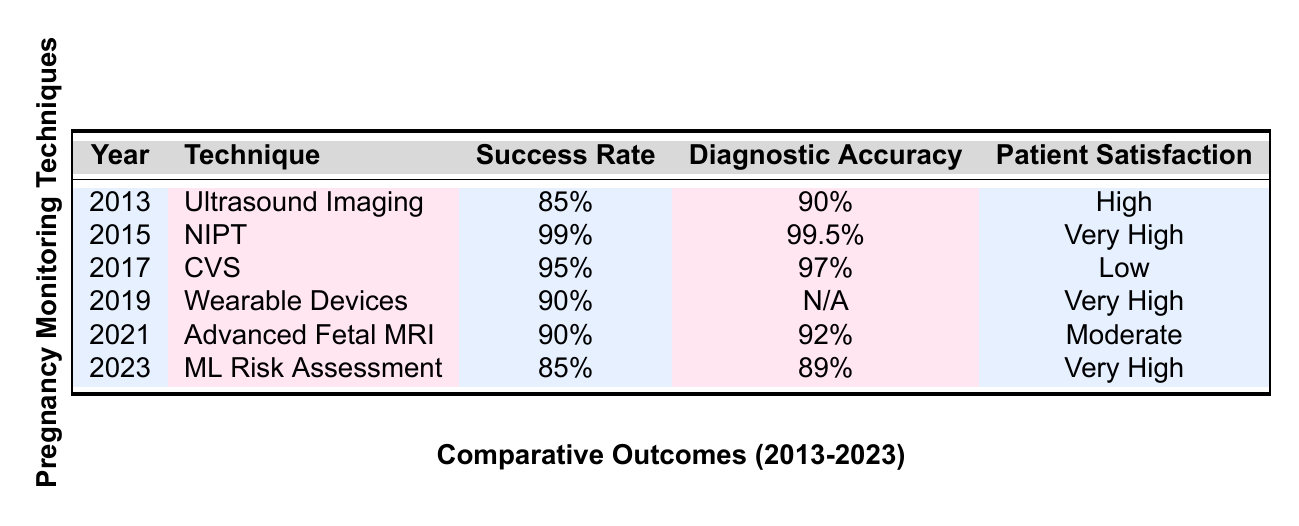What is the highest success rate among the techniques listed? The highest success rate in the table is found under Non-Invasive Prenatal Testing (NIPT) with a success rate of 99%.
Answer: 99% Which technique had the lowest patient satisfaction? The technique with the lowest patient satisfaction is Chorionic Villus Sampling (CVS), which is rated as Low.
Answer: Low What is the average diagnostic accuracy of the techniques listed from 2013 to 2023? The diagnostic accuracies are 90%, 99.5%, 97%, N/A (not available), 92%, and 89%. Excluding N/A, the numeric values sum up to 90 + 99.5 + 97 + 92 + 89 = 467, and there are 5 valid entries, so the average is 467/5 = 93.4%.
Answer: 93.4% Did any technique in 2022 have a diagnostic accuracy listed? No, in 2022, the technique Smartphone Apps for Monitoring has a diagnostic accuracy listed as N/A, which means it is not available.
Answer: No Which technique introduced in 2019 has the highest patient satisfaction rating? The technique introduced in 2019 is Continuous Monitoring with Wearable Devices, which has a patient satisfaction rating of Very High, making it the highest for that year.
Answer: Very High What is the difference in success rates between 4D Ultrasound Imaging (2020) and Non-Invasive Prenatal Testing (NIPT) (2015)? The success rates are 88% for 4D Ultrasound Imaging and 99% for NIPT. The difference is 99% - 88% = 11%.
Answer: 11% Which techniques have a success rate below 85%? The techniques with a success rate below 85% are Telemedicine Consultations in 2018 (75%) and Smartphone Apps for Monitoring in 2022 (70%).
Answer: 75%, 70% If we consider only techniques with high patient satisfaction, what are their success rates? The techniques that have High or Very High patient satisfaction ratings are Ultrasound Imaging (85%), Non-Invasive Prenatal Testing (99%), Continuous Monitoring with Wearable Devices (90%), 4D Ultrasound Imaging (88%), and Machine Learning Risk Assessment (85%). Their success rates are 85%, 99%, 90%, 88%, and 85%.
Answer: 85%, 99%, 90%, 88%, 85% In which year did the technique with the second-highest success rate appear? The second-highest success rate is 98% from Amniocentesis in 2016. Therefore, the year is 2016.
Answer: 2016 Which technique showed an improvement in patient satisfaction from 2013 to 2023? Non-Invasive Prenatal Testing (NIPT) improved from High in 2013 to Very High in 2023 as indicated by Machine Learning Algorithms for Risk Assessment.
Answer: NIPT 